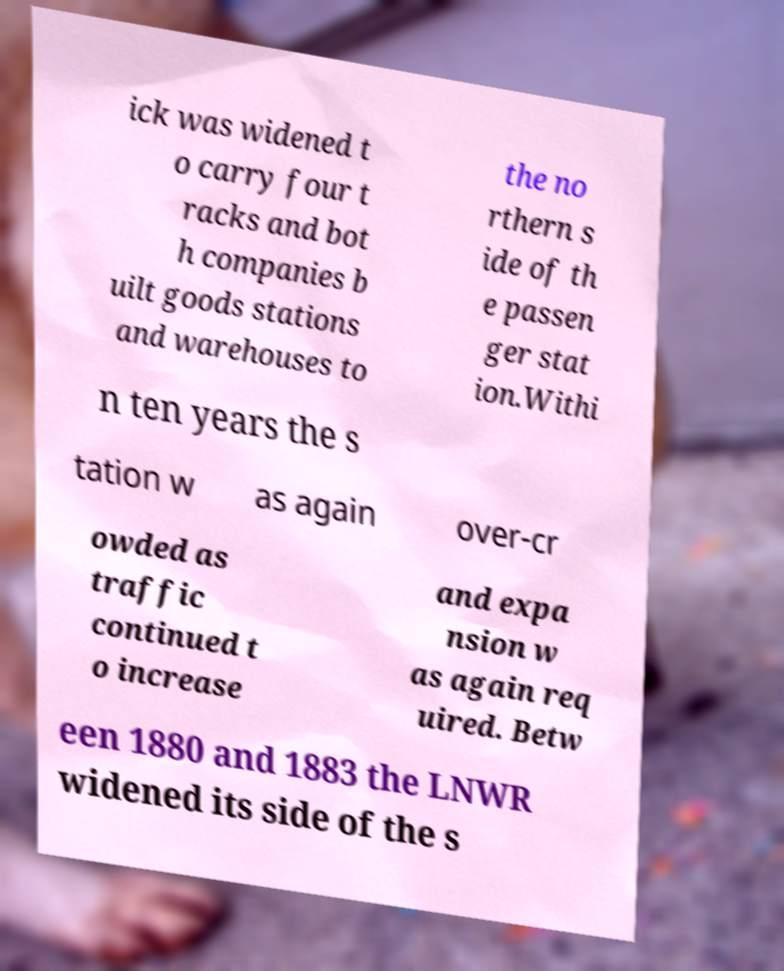For documentation purposes, I need the text within this image transcribed. Could you provide that? ick was widened t o carry four t racks and bot h companies b uilt goods stations and warehouses to the no rthern s ide of th e passen ger stat ion.Withi n ten years the s tation w as again over-cr owded as traffic continued t o increase and expa nsion w as again req uired. Betw een 1880 and 1883 the LNWR widened its side of the s 